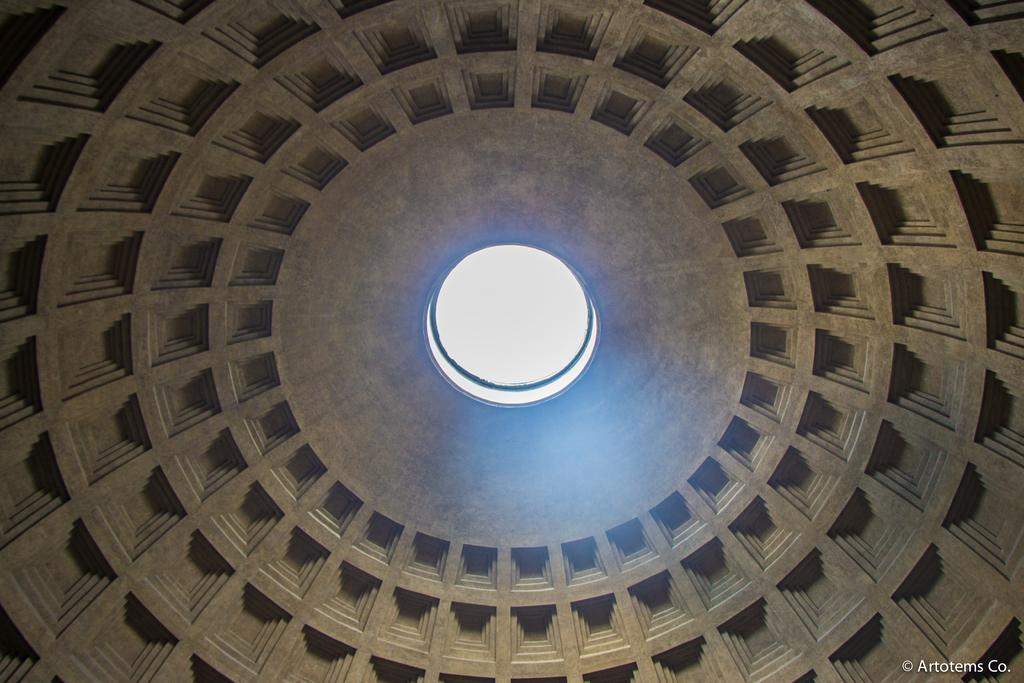What is the source of light in the image? The light is on an object in the image. Can you describe the object that the light is on? The object has designs on it. Is there any text visible in the image? Yes, there is text in the bottom right corner of the image. What type of berry is growing on the object in the image? There are no berries present in the image; the object has designs on it. How does the hair on the object in the image contribute to its overall appearance? There is no hair present on the object in the image; it has designs instead. 